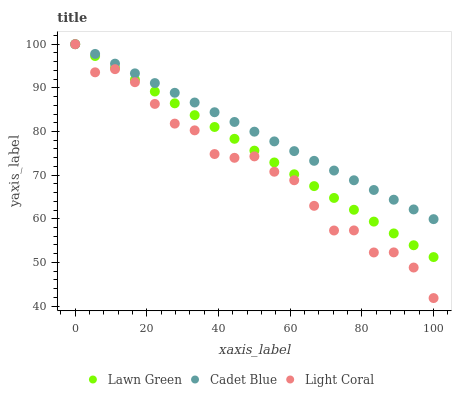Does Light Coral have the minimum area under the curve?
Answer yes or no. Yes. Does Cadet Blue have the maximum area under the curve?
Answer yes or no. Yes. Does Lawn Green have the minimum area under the curve?
Answer yes or no. No. Does Lawn Green have the maximum area under the curve?
Answer yes or no. No. Is Lawn Green the smoothest?
Answer yes or no. Yes. Is Light Coral the roughest?
Answer yes or no. Yes. Is Cadet Blue the smoothest?
Answer yes or no. No. Is Cadet Blue the roughest?
Answer yes or no. No. Does Light Coral have the lowest value?
Answer yes or no. Yes. Does Lawn Green have the lowest value?
Answer yes or no. No. Does Cadet Blue have the highest value?
Answer yes or no. Yes. Does Cadet Blue intersect Light Coral?
Answer yes or no. Yes. Is Cadet Blue less than Light Coral?
Answer yes or no. No. Is Cadet Blue greater than Light Coral?
Answer yes or no. No. 